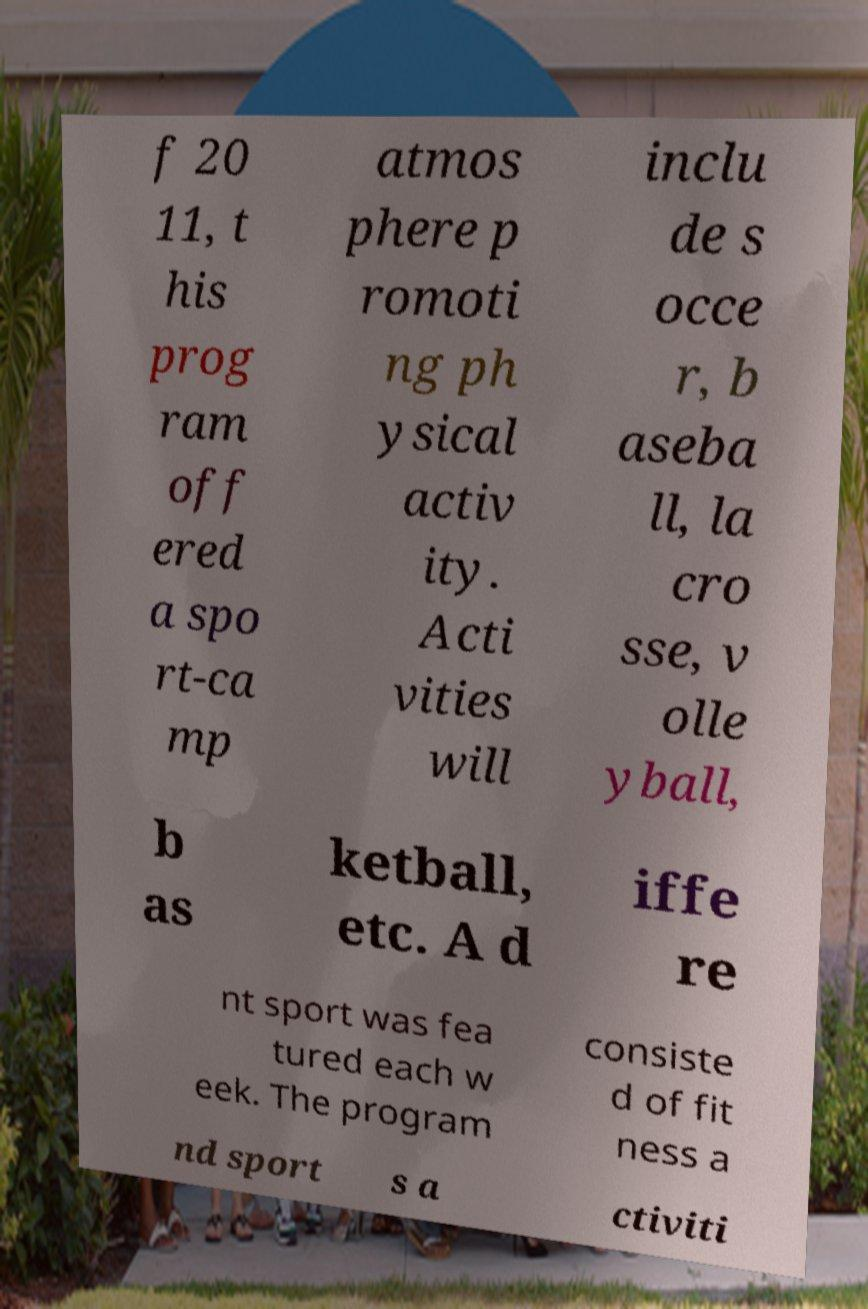I need the written content from this picture converted into text. Can you do that? f 20 11, t his prog ram off ered a spo rt-ca mp atmos phere p romoti ng ph ysical activ ity. Acti vities will inclu de s occe r, b aseba ll, la cro sse, v olle yball, b as ketball, etc. A d iffe re nt sport was fea tured each w eek. The program consiste d of fit ness a nd sport s a ctiviti 